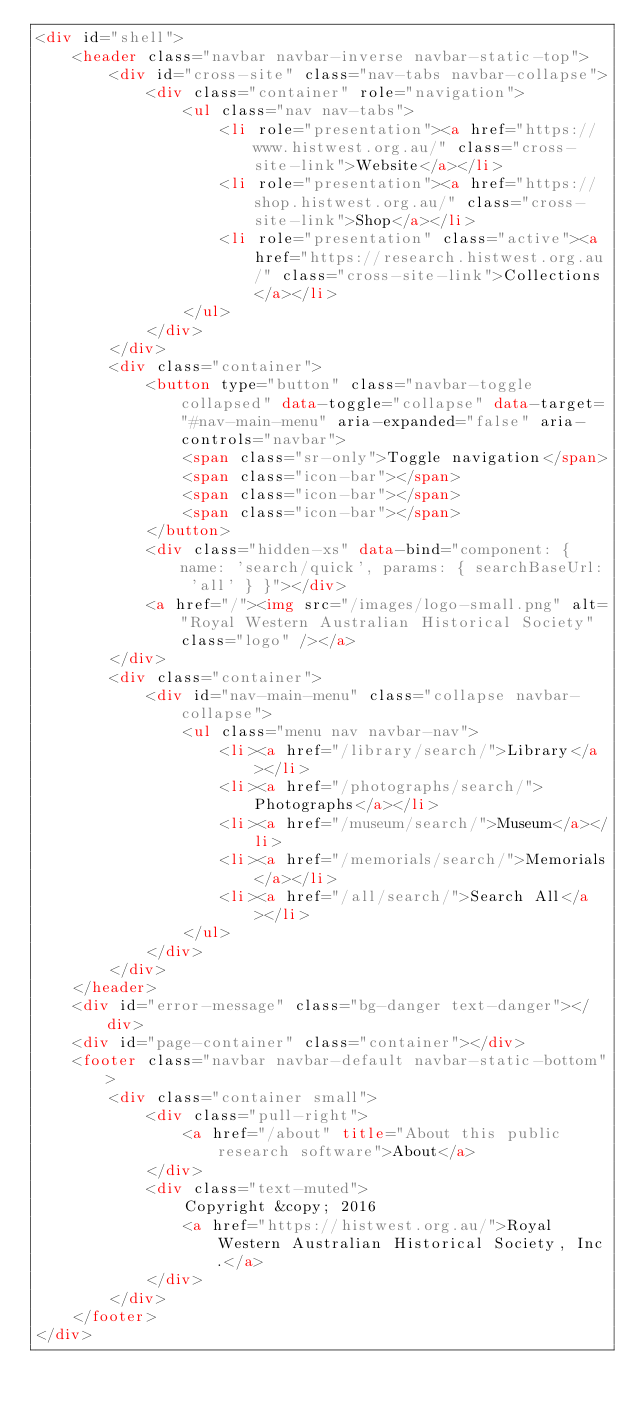<code> <loc_0><loc_0><loc_500><loc_500><_HTML_><div id="shell">
    <header class="navbar navbar-inverse navbar-static-top">
        <div id="cross-site" class="nav-tabs navbar-collapse">
            <div class="container" role="navigation">
                <ul class="nav nav-tabs">
                    <li role="presentation"><a href="https://www.histwest.org.au/" class="cross-site-link">Website</a></li>
                    <li role="presentation"><a href="https://shop.histwest.org.au/" class="cross-site-link">Shop</a></li>
                    <li role="presentation" class="active"><a href="https://research.histwest.org.au/" class="cross-site-link">Collections</a></li>
                </ul>
            </div>
        </div>
        <div class="container">
            <button type="button" class="navbar-toggle collapsed" data-toggle="collapse" data-target="#nav-main-menu" aria-expanded="false" aria-controls="navbar">
                <span class="sr-only">Toggle navigation</span>
                <span class="icon-bar"></span>
                <span class="icon-bar"></span>
                <span class="icon-bar"></span>
            </button>
            <div class="hidden-xs" data-bind="component: { name: 'search/quick', params: { searchBaseUrl: 'all' } }"></div>
            <a href="/"><img src="/images/logo-small.png" alt="Royal Western Australian Historical Society" class="logo" /></a>
        </div>
        <div class="container">
            <div id="nav-main-menu" class="collapse navbar-collapse">
                <ul class="menu nav navbar-nav">
                    <li><a href="/library/search/">Library</a></li>
                    <li><a href="/photographs/search/">Photographs</a></li>
                    <li><a href="/museum/search/">Museum</a></li>
                    <li><a href="/memorials/search/">Memorials</a></li>
                    <li><a href="/all/search/">Search All</a></li>
                </ul>
            </div>
        </div>
    </header>
    <div id="error-message" class="bg-danger text-danger"></div>
    <div id="page-container" class="container"></div>
    <footer class="navbar navbar-default navbar-static-bottom">
        <div class="container small">
            <div class="pull-right">
                <a href="/about" title="About this public research software">About</a>
            </div>
            <div class="text-muted">
                Copyright &copy; 2016
                <a href="https://histwest.org.au/">Royal Western Australian Historical Society, Inc.</a>
            </div>
        </div>
    </footer>
</div>
</code> 